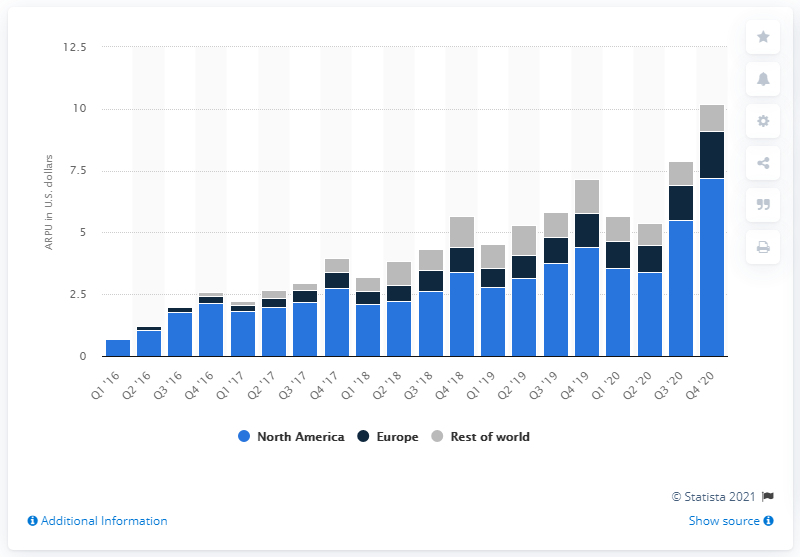Identify some key points in this picture. As of the fourth quarter of 2020, Snapchat's ARPU (Average Revenue Per User) was $7.19 per quarter. In the fourth quarter of 2020, Snapchat's ARPU was 5.49. 